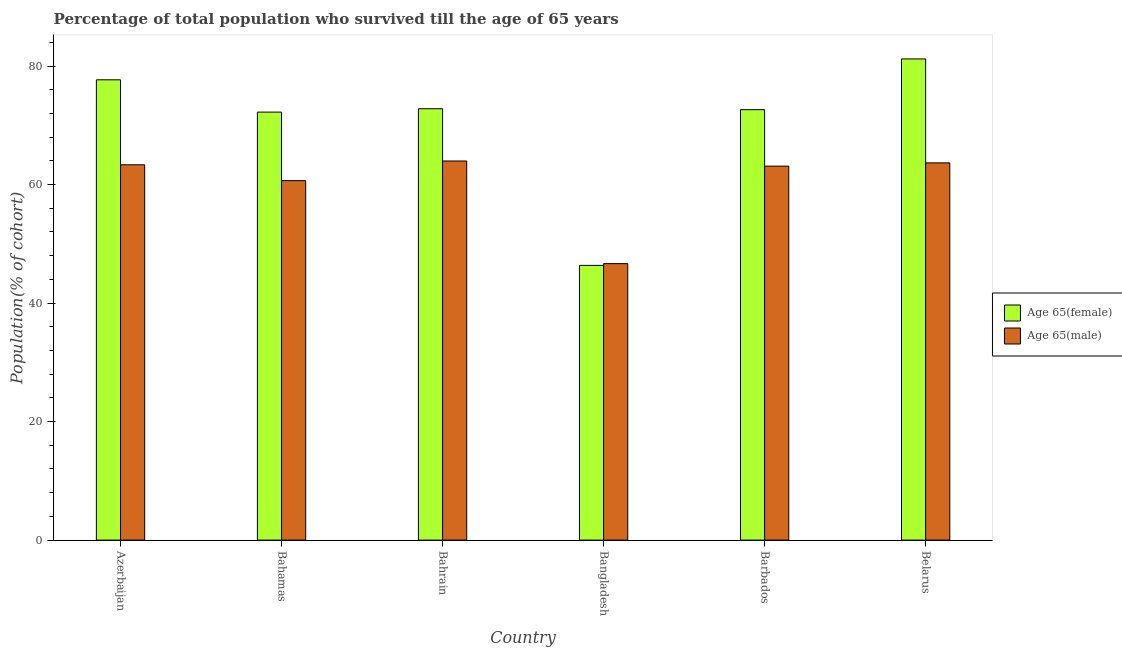How many groups of bars are there?
Provide a succinct answer. 6. What is the label of the 2nd group of bars from the left?
Your response must be concise. Bahamas. What is the percentage of male population who survived till age of 65 in Bahamas?
Offer a terse response. 60.66. Across all countries, what is the maximum percentage of female population who survived till age of 65?
Ensure brevity in your answer.  81.19. Across all countries, what is the minimum percentage of male population who survived till age of 65?
Your response must be concise. 46.65. In which country was the percentage of female population who survived till age of 65 maximum?
Ensure brevity in your answer.  Belarus. What is the total percentage of male population who survived till age of 65 in the graph?
Give a very brief answer. 361.37. What is the difference between the percentage of female population who survived till age of 65 in Barbados and that in Belarus?
Your response must be concise. -8.56. What is the difference between the percentage of female population who survived till age of 65 in Bahamas and the percentage of male population who survived till age of 65 in Bahrain?
Keep it short and to the point. 8.25. What is the average percentage of female population who survived till age of 65 per country?
Keep it short and to the point. 70.48. What is the difference between the percentage of female population who survived till age of 65 and percentage of male population who survived till age of 65 in Bahamas?
Your response must be concise. 11.56. What is the ratio of the percentage of male population who survived till age of 65 in Bangladesh to that in Belarus?
Your answer should be very brief. 0.73. What is the difference between the highest and the second highest percentage of male population who survived till age of 65?
Your answer should be very brief. 0.32. What is the difference between the highest and the lowest percentage of female population who survived till age of 65?
Offer a terse response. 34.84. In how many countries, is the percentage of female population who survived till age of 65 greater than the average percentage of female population who survived till age of 65 taken over all countries?
Offer a very short reply. 5. What does the 1st bar from the left in Bahrain represents?
Provide a succinct answer. Age 65(female). What does the 2nd bar from the right in Barbados represents?
Ensure brevity in your answer.  Age 65(female). Are all the bars in the graph horizontal?
Give a very brief answer. No. Are the values on the major ticks of Y-axis written in scientific E-notation?
Make the answer very short. No. Where does the legend appear in the graph?
Offer a terse response. Center right. What is the title of the graph?
Offer a terse response. Percentage of total population who survived till the age of 65 years. What is the label or title of the Y-axis?
Offer a very short reply. Population(% of cohort). What is the Population(% of cohort) in Age 65(female) in Azerbaijan?
Make the answer very short. 77.67. What is the Population(% of cohort) of Age 65(male) in Azerbaijan?
Give a very brief answer. 63.33. What is the Population(% of cohort) in Age 65(female) in Bahamas?
Provide a succinct answer. 72.22. What is the Population(% of cohort) of Age 65(male) in Bahamas?
Offer a terse response. 60.66. What is the Population(% of cohort) of Age 65(female) in Bahrain?
Your response must be concise. 72.79. What is the Population(% of cohort) of Age 65(male) in Bahrain?
Keep it short and to the point. 63.97. What is the Population(% of cohort) of Age 65(female) in Bangladesh?
Ensure brevity in your answer.  46.36. What is the Population(% of cohort) in Age 65(male) in Bangladesh?
Make the answer very short. 46.65. What is the Population(% of cohort) in Age 65(female) in Barbados?
Ensure brevity in your answer.  72.63. What is the Population(% of cohort) in Age 65(male) in Barbados?
Make the answer very short. 63.11. What is the Population(% of cohort) in Age 65(female) in Belarus?
Ensure brevity in your answer.  81.19. What is the Population(% of cohort) in Age 65(male) in Belarus?
Give a very brief answer. 63.65. Across all countries, what is the maximum Population(% of cohort) in Age 65(female)?
Offer a very short reply. 81.19. Across all countries, what is the maximum Population(% of cohort) of Age 65(male)?
Provide a succinct answer. 63.97. Across all countries, what is the minimum Population(% of cohort) in Age 65(female)?
Offer a very short reply. 46.36. Across all countries, what is the minimum Population(% of cohort) of Age 65(male)?
Provide a short and direct response. 46.65. What is the total Population(% of cohort) of Age 65(female) in the graph?
Offer a terse response. 422.86. What is the total Population(% of cohort) in Age 65(male) in the graph?
Offer a very short reply. 361.37. What is the difference between the Population(% of cohort) in Age 65(female) in Azerbaijan and that in Bahamas?
Ensure brevity in your answer.  5.45. What is the difference between the Population(% of cohort) in Age 65(male) in Azerbaijan and that in Bahamas?
Provide a short and direct response. 2.67. What is the difference between the Population(% of cohort) of Age 65(female) in Azerbaijan and that in Bahrain?
Your answer should be very brief. 4.88. What is the difference between the Population(% of cohort) in Age 65(male) in Azerbaijan and that in Bahrain?
Give a very brief answer. -0.64. What is the difference between the Population(% of cohort) in Age 65(female) in Azerbaijan and that in Bangladesh?
Your response must be concise. 31.32. What is the difference between the Population(% of cohort) of Age 65(male) in Azerbaijan and that in Bangladesh?
Your answer should be very brief. 16.68. What is the difference between the Population(% of cohort) of Age 65(female) in Azerbaijan and that in Barbados?
Your answer should be very brief. 5.04. What is the difference between the Population(% of cohort) in Age 65(male) in Azerbaijan and that in Barbados?
Your answer should be compact. 0.22. What is the difference between the Population(% of cohort) in Age 65(female) in Azerbaijan and that in Belarus?
Ensure brevity in your answer.  -3.52. What is the difference between the Population(% of cohort) in Age 65(male) in Azerbaijan and that in Belarus?
Offer a terse response. -0.32. What is the difference between the Population(% of cohort) in Age 65(female) in Bahamas and that in Bahrain?
Provide a succinct answer. -0.57. What is the difference between the Population(% of cohort) in Age 65(male) in Bahamas and that in Bahrain?
Ensure brevity in your answer.  -3.31. What is the difference between the Population(% of cohort) in Age 65(female) in Bahamas and that in Bangladesh?
Ensure brevity in your answer.  25.87. What is the difference between the Population(% of cohort) in Age 65(male) in Bahamas and that in Bangladesh?
Provide a succinct answer. 14.01. What is the difference between the Population(% of cohort) in Age 65(female) in Bahamas and that in Barbados?
Offer a very short reply. -0.41. What is the difference between the Population(% of cohort) in Age 65(male) in Bahamas and that in Barbados?
Your answer should be compact. -2.45. What is the difference between the Population(% of cohort) in Age 65(female) in Bahamas and that in Belarus?
Your answer should be compact. -8.97. What is the difference between the Population(% of cohort) in Age 65(male) in Bahamas and that in Belarus?
Ensure brevity in your answer.  -2.99. What is the difference between the Population(% of cohort) in Age 65(female) in Bahrain and that in Bangladesh?
Keep it short and to the point. 26.43. What is the difference between the Population(% of cohort) of Age 65(male) in Bahrain and that in Bangladesh?
Provide a succinct answer. 17.32. What is the difference between the Population(% of cohort) of Age 65(female) in Bahrain and that in Barbados?
Ensure brevity in your answer.  0.16. What is the difference between the Population(% of cohort) in Age 65(male) in Bahrain and that in Barbados?
Make the answer very short. 0.87. What is the difference between the Population(% of cohort) of Age 65(female) in Bahrain and that in Belarus?
Offer a terse response. -8.4. What is the difference between the Population(% of cohort) in Age 65(male) in Bahrain and that in Belarus?
Your response must be concise. 0.32. What is the difference between the Population(% of cohort) of Age 65(female) in Bangladesh and that in Barbados?
Provide a short and direct response. -26.28. What is the difference between the Population(% of cohort) of Age 65(male) in Bangladesh and that in Barbados?
Give a very brief answer. -16.45. What is the difference between the Population(% of cohort) of Age 65(female) in Bangladesh and that in Belarus?
Ensure brevity in your answer.  -34.84. What is the difference between the Population(% of cohort) of Age 65(male) in Bangladesh and that in Belarus?
Give a very brief answer. -17. What is the difference between the Population(% of cohort) in Age 65(female) in Barbados and that in Belarus?
Your response must be concise. -8.56. What is the difference between the Population(% of cohort) of Age 65(male) in Barbados and that in Belarus?
Make the answer very short. -0.55. What is the difference between the Population(% of cohort) in Age 65(female) in Azerbaijan and the Population(% of cohort) in Age 65(male) in Bahamas?
Keep it short and to the point. 17.01. What is the difference between the Population(% of cohort) in Age 65(female) in Azerbaijan and the Population(% of cohort) in Age 65(male) in Bahrain?
Give a very brief answer. 13.7. What is the difference between the Population(% of cohort) of Age 65(female) in Azerbaijan and the Population(% of cohort) of Age 65(male) in Bangladesh?
Offer a terse response. 31.02. What is the difference between the Population(% of cohort) in Age 65(female) in Azerbaijan and the Population(% of cohort) in Age 65(male) in Barbados?
Your answer should be very brief. 14.57. What is the difference between the Population(% of cohort) in Age 65(female) in Azerbaijan and the Population(% of cohort) in Age 65(male) in Belarus?
Keep it short and to the point. 14.02. What is the difference between the Population(% of cohort) of Age 65(female) in Bahamas and the Population(% of cohort) of Age 65(male) in Bahrain?
Offer a very short reply. 8.25. What is the difference between the Population(% of cohort) in Age 65(female) in Bahamas and the Population(% of cohort) in Age 65(male) in Bangladesh?
Provide a succinct answer. 25.57. What is the difference between the Population(% of cohort) of Age 65(female) in Bahamas and the Population(% of cohort) of Age 65(male) in Barbados?
Keep it short and to the point. 9.12. What is the difference between the Population(% of cohort) of Age 65(female) in Bahamas and the Population(% of cohort) of Age 65(male) in Belarus?
Your answer should be compact. 8.57. What is the difference between the Population(% of cohort) in Age 65(female) in Bahrain and the Population(% of cohort) in Age 65(male) in Bangladesh?
Keep it short and to the point. 26.14. What is the difference between the Population(% of cohort) in Age 65(female) in Bahrain and the Population(% of cohort) in Age 65(male) in Barbados?
Keep it short and to the point. 9.68. What is the difference between the Population(% of cohort) of Age 65(female) in Bahrain and the Population(% of cohort) of Age 65(male) in Belarus?
Provide a succinct answer. 9.14. What is the difference between the Population(% of cohort) in Age 65(female) in Bangladesh and the Population(% of cohort) in Age 65(male) in Barbados?
Your response must be concise. -16.75. What is the difference between the Population(% of cohort) of Age 65(female) in Bangladesh and the Population(% of cohort) of Age 65(male) in Belarus?
Your response must be concise. -17.3. What is the difference between the Population(% of cohort) in Age 65(female) in Barbados and the Population(% of cohort) in Age 65(male) in Belarus?
Provide a short and direct response. 8.98. What is the average Population(% of cohort) of Age 65(female) per country?
Provide a short and direct response. 70.48. What is the average Population(% of cohort) in Age 65(male) per country?
Provide a succinct answer. 60.23. What is the difference between the Population(% of cohort) in Age 65(female) and Population(% of cohort) in Age 65(male) in Azerbaijan?
Your answer should be compact. 14.34. What is the difference between the Population(% of cohort) of Age 65(female) and Population(% of cohort) of Age 65(male) in Bahamas?
Offer a terse response. 11.56. What is the difference between the Population(% of cohort) of Age 65(female) and Population(% of cohort) of Age 65(male) in Bahrain?
Keep it short and to the point. 8.82. What is the difference between the Population(% of cohort) in Age 65(female) and Population(% of cohort) in Age 65(male) in Bangladesh?
Give a very brief answer. -0.3. What is the difference between the Population(% of cohort) of Age 65(female) and Population(% of cohort) of Age 65(male) in Barbados?
Offer a terse response. 9.53. What is the difference between the Population(% of cohort) in Age 65(female) and Population(% of cohort) in Age 65(male) in Belarus?
Keep it short and to the point. 17.54. What is the ratio of the Population(% of cohort) of Age 65(female) in Azerbaijan to that in Bahamas?
Provide a succinct answer. 1.08. What is the ratio of the Population(% of cohort) of Age 65(male) in Azerbaijan to that in Bahamas?
Your response must be concise. 1.04. What is the ratio of the Population(% of cohort) of Age 65(female) in Azerbaijan to that in Bahrain?
Provide a short and direct response. 1.07. What is the ratio of the Population(% of cohort) in Age 65(female) in Azerbaijan to that in Bangladesh?
Give a very brief answer. 1.68. What is the ratio of the Population(% of cohort) in Age 65(male) in Azerbaijan to that in Bangladesh?
Keep it short and to the point. 1.36. What is the ratio of the Population(% of cohort) in Age 65(female) in Azerbaijan to that in Barbados?
Provide a short and direct response. 1.07. What is the ratio of the Population(% of cohort) of Age 65(male) in Azerbaijan to that in Barbados?
Give a very brief answer. 1. What is the ratio of the Population(% of cohort) in Age 65(female) in Azerbaijan to that in Belarus?
Your response must be concise. 0.96. What is the ratio of the Population(% of cohort) of Age 65(female) in Bahamas to that in Bahrain?
Provide a succinct answer. 0.99. What is the ratio of the Population(% of cohort) of Age 65(male) in Bahamas to that in Bahrain?
Your response must be concise. 0.95. What is the ratio of the Population(% of cohort) in Age 65(female) in Bahamas to that in Bangladesh?
Provide a short and direct response. 1.56. What is the ratio of the Population(% of cohort) of Age 65(male) in Bahamas to that in Bangladesh?
Give a very brief answer. 1.3. What is the ratio of the Population(% of cohort) in Age 65(male) in Bahamas to that in Barbados?
Your answer should be compact. 0.96. What is the ratio of the Population(% of cohort) of Age 65(female) in Bahamas to that in Belarus?
Make the answer very short. 0.89. What is the ratio of the Population(% of cohort) of Age 65(male) in Bahamas to that in Belarus?
Provide a short and direct response. 0.95. What is the ratio of the Population(% of cohort) in Age 65(female) in Bahrain to that in Bangladesh?
Offer a terse response. 1.57. What is the ratio of the Population(% of cohort) of Age 65(male) in Bahrain to that in Bangladesh?
Provide a short and direct response. 1.37. What is the ratio of the Population(% of cohort) in Age 65(female) in Bahrain to that in Barbados?
Your answer should be very brief. 1. What is the ratio of the Population(% of cohort) in Age 65(male) in Bahrain to that in Barbados?
Provide a succinct answer. 1.01. What is the ratio of the Population(% of cohort) of Age 65(female) in Bahrain to that in Belarus?
Your answer should be compact. 0.9. What is the ratio of the Population(% of cohort) of Age 65(male) in Bahrain to that in Belarus?
Make the answer very short. 1. What is the ratio of the Population(% of cohort) of Age 65(female) in Bangladesh to that in Barbados?
Make the answer very short. 0.64. What is the ratio of the Population(% of cohort) in Age 65(male) in Bangladesh to that in Barbados?
Provide a short and direct response. 0.74. What is the ratio of the Population(% of cohort) of Age 65(female) in Bangladesh to that in Belarus?
Your answer should be very brief. 0.57. What is the ratio of the Population(% of cohort) in Age 65(male) in Bangladesh to that in Belarus?
Offer a terse response. 0.73. What is the ratio of the Population(% of cohort) in Age 65(female) in Barbados to that in Belarus?
Ensure brevity in your answer.  0.89. What is the difference between the highest and the second highest Population(% of cohort) in Age 65(female)?
Your answer should be compact. 3.52. What is the difference between the highest and the second highest Population(% of cohort) of Age 65(male)?
Offer a terse response. 0.32. What is the difference between the highest and the lowest Population(% of cohort) in Age 65(female)?
Offer a terse response. 34.84. What is the difference between the highest and the lowest Population(% of cohort) in Age 65(male)?
Provide a succinct answer. 17.32. 